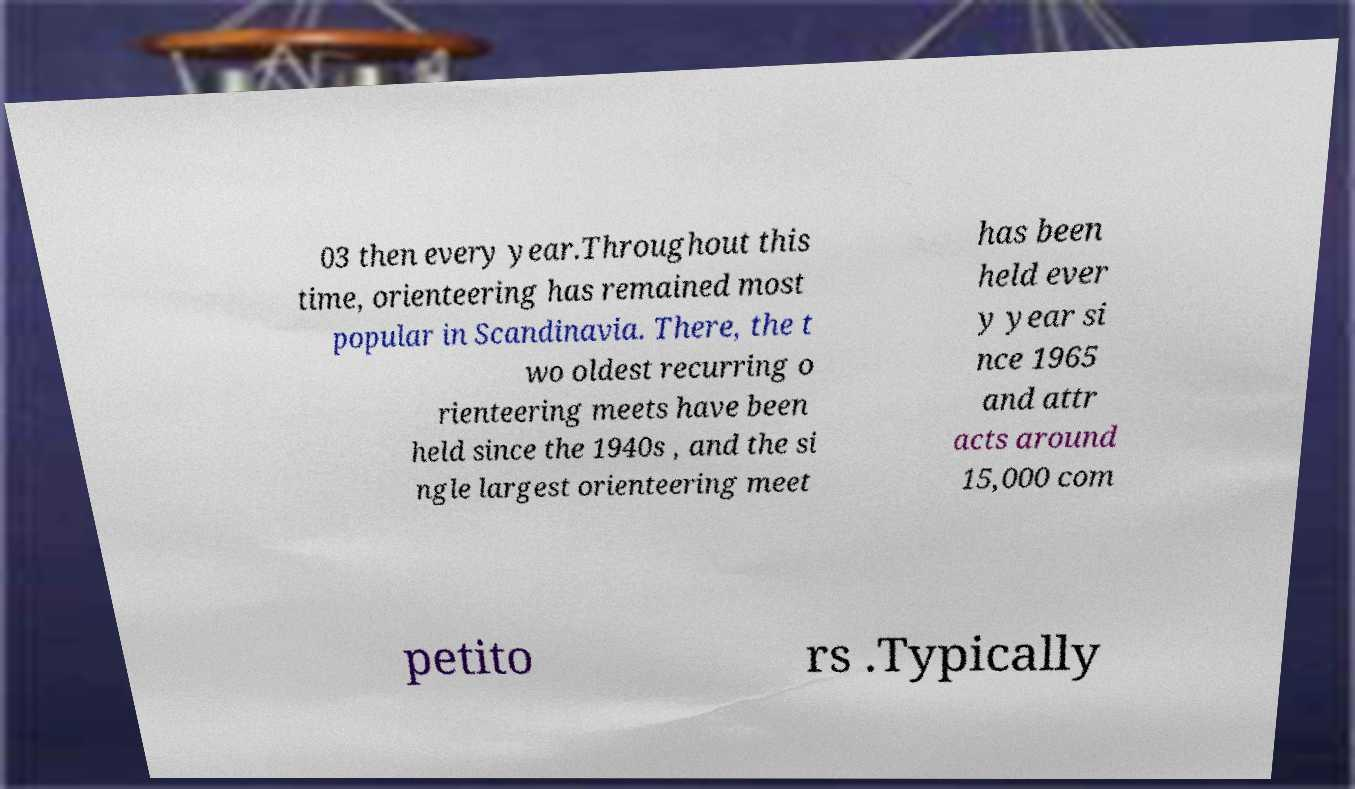Could you assist in decoding the text presented in this image and type it out clearly? 03 then every year.Throughout this time, orienteering has remained most popular in Scandinavia. There, the t wo oldest recurring o rienteering meets have been held since the 1940s , and the si ngle largest orienteering meet has been held ever y year si nce 1965 and attr acts around 15,000 com petito rs .Typically 